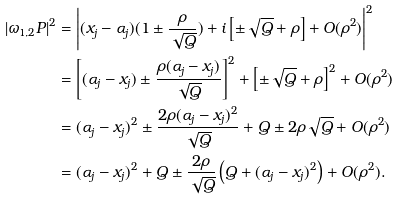Convert formula to latex. <formula><loc_0><loc_0><loc_500><loc_500>| \omega _ { 1 , 2 } P | ^ { 2 } & = \left | ( x _ { j } - \alpha _ { j } ) ( 1 \pm \frac { \rho } { \sqrt { Q } } ) + i \left [ \pm \sqrt { Q } + \rho \right ] + O ( \rho ^ { 2 } ) \right | ^ { 2 } \\ & = \left [ ( \alpha _ { j } - x _ { j } ) \pm \frac { \rho ( \alpha _ { j } - x _ { j } ) } { \sqrt { Q } } \right ] ^ { 2 } + \left [ \pm \sqrt { Q } + \rho \right ] ^ { 2 } + O ( \rho ^ { 2 } ) \\ & = ( \alpha _ { j } - x _ { j } ) ^ { 2 } \pm \frac { 2 \rho ( \alpha _ { j } - x _ { j } ) ^ { 2 } } { \sqrt { Q } } + Q \pm 2 \rho \sqrt { Q } + O ( \rho ^ { 2 } ) \\ & = ( \alpha _ { j } - x _ { j } ) ^ { 2 } + Q \pm \frac { 2 \rho } { \sqrt { Q } } \left ( Q + ( \alpha _ { j } - x _ { j } ) ^ { 2 } \right ) + O ( \rho ^ { 2 } ) . \\</formula> 